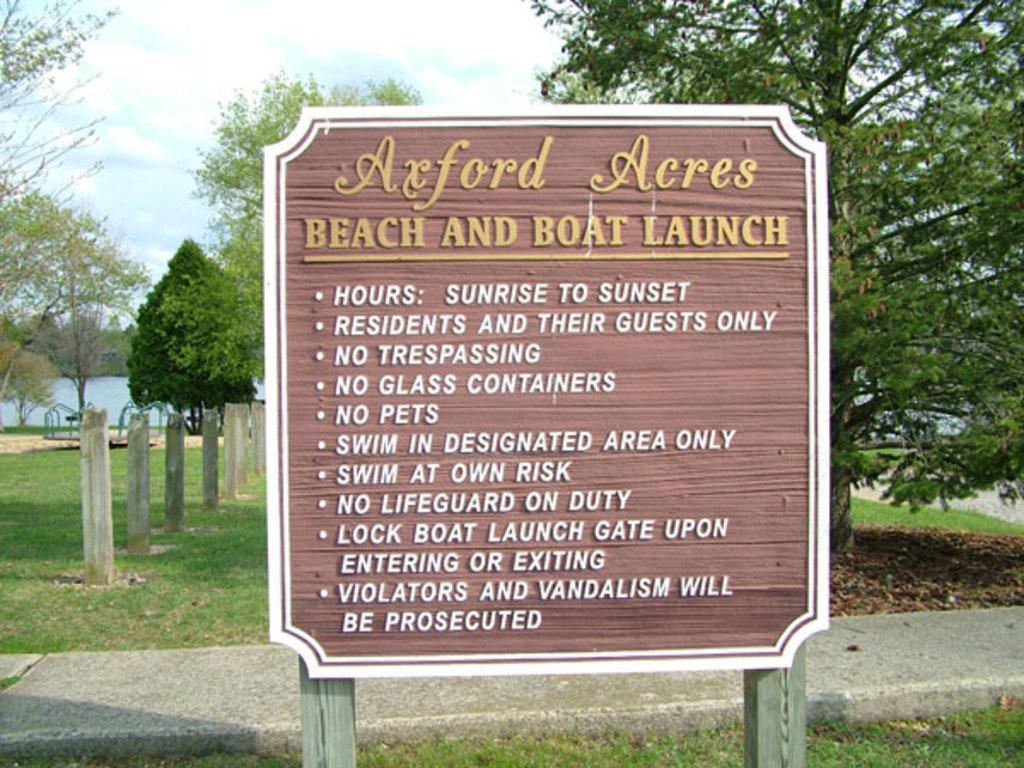Could you give a brief overview of what you see in this image? in this image we can see a board. Behind the board poles, grassy land and trees are there. The sky is covered with clouds. 